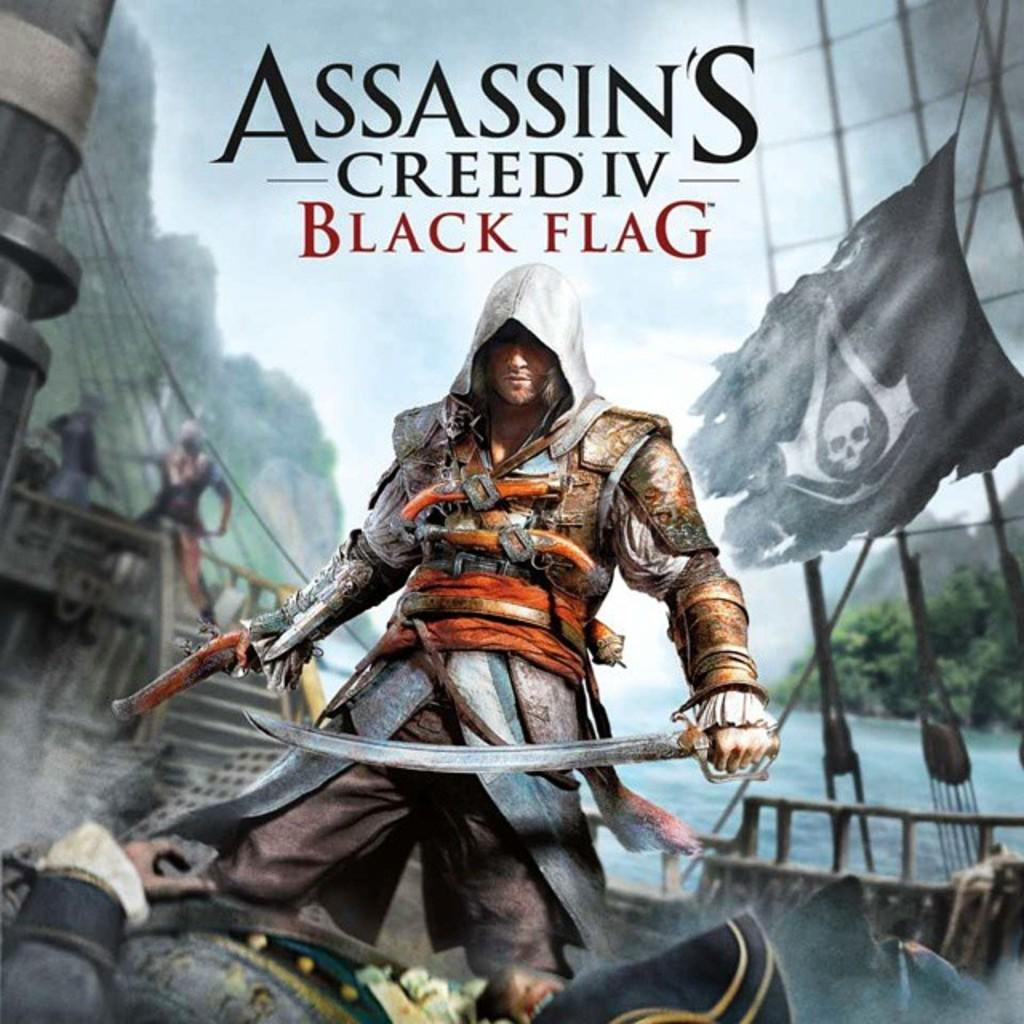<image>
Provide a brief description of the given image. Cover of a video game titled Assassin's Creed IV Black Flag. 